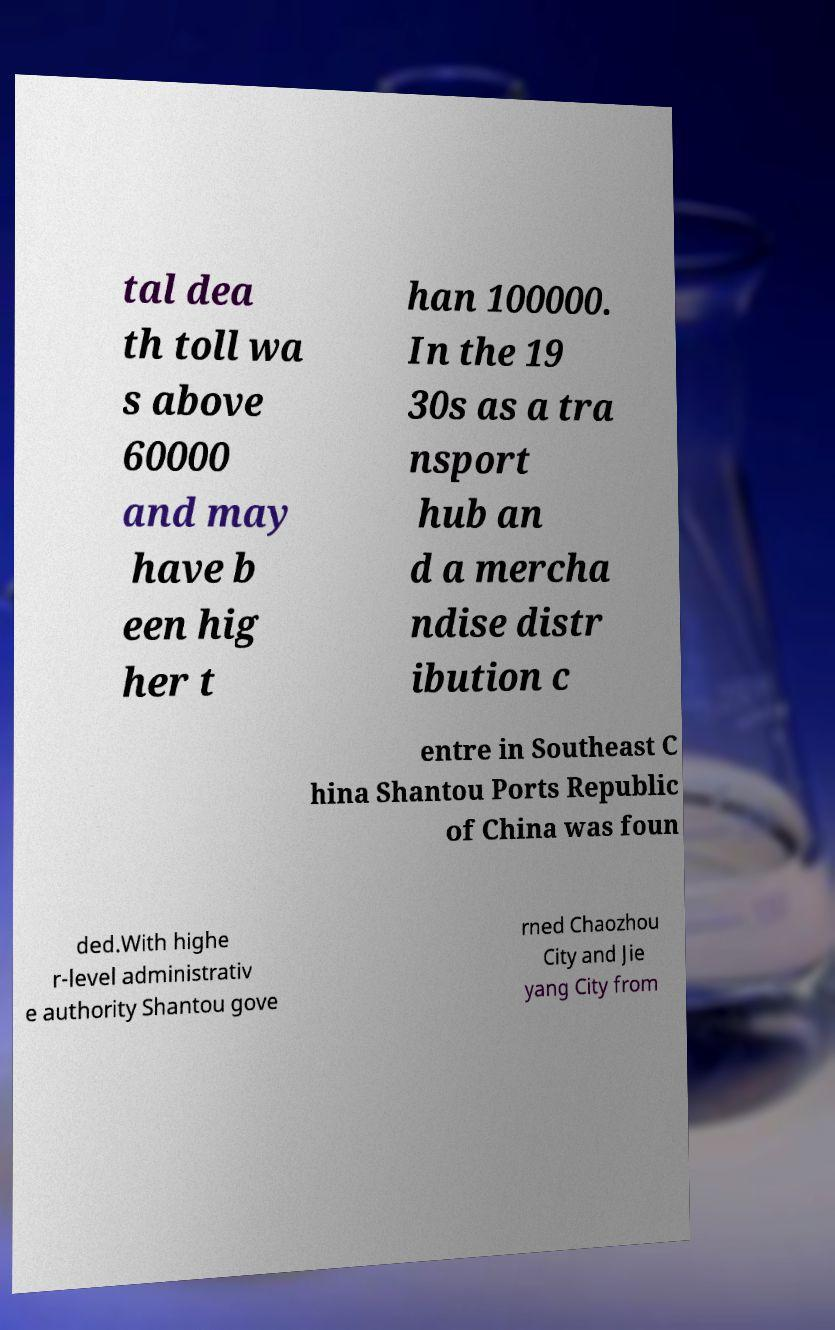Please identify and transcribe the text found in this image. tal dea th toll wa s above 60000 and may have b een hig her t han 100000. In the 19 30s as a tra nsport hub an d a mercha ndise distr ibution c entre in Southeast C hina Shantou Ports Republic of China was foun ded.With highe r-level administrativ e authority Shantou gove rned Chaozhou City and Jie yang City from 